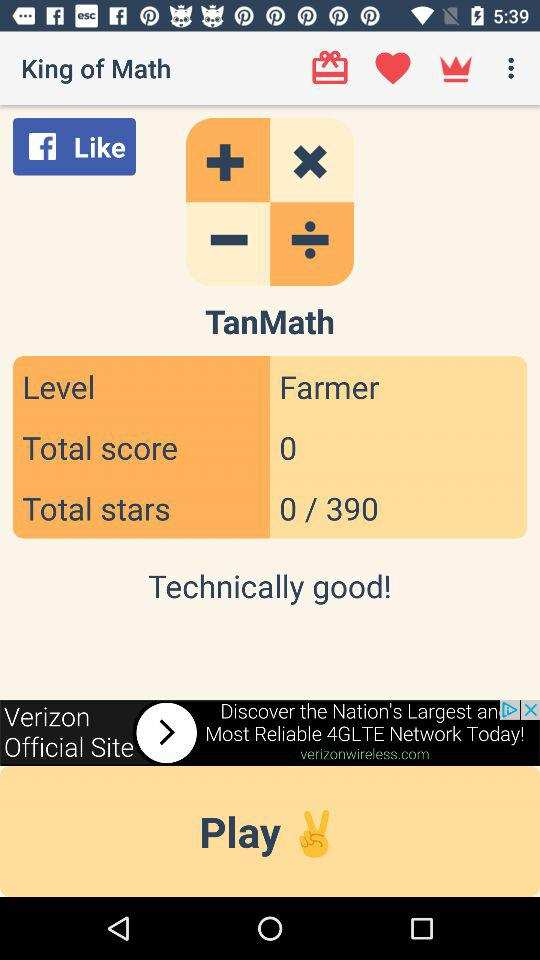What is the total score? The total score is 0. 